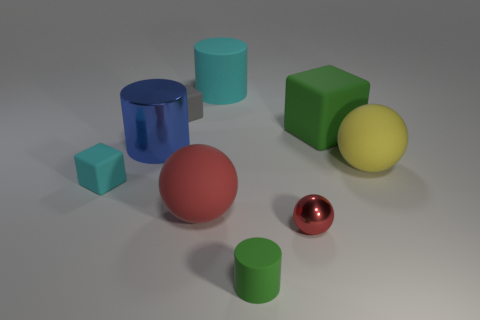How many other things are there of the same color as the metal ball?
Offer a terse response. 1. What number of cubes are either tiny cyan things or green objects?
Provide a succinct answer. 2. Are there any gray objects right of the matte cube that is to the right of the large rubber cylinder?
Keep it short and to the point. No. Is the number of small red objects less than the number of small matte blocks?
Make the answer very short. Yes. How many large cyan rubber objects are the same shape as the big blue metal object?
Offer a terse response. 1. How many gray objects are large cylinders or rubber things?
Offer a terse response. 1. What size is the red ball that is to the right of the thing in front of the red shiny ball?
Offer a terse response. Small. There is another small object that is the same shape as the red matte object; what is it made of?
Offer a terse response. Metal. How many red shiny cubes are the same size as the green cylinder?
Offer a terse response. 0. Does the red metal object have the same size as the red matte thing?
Keep it short and to the point. No. 